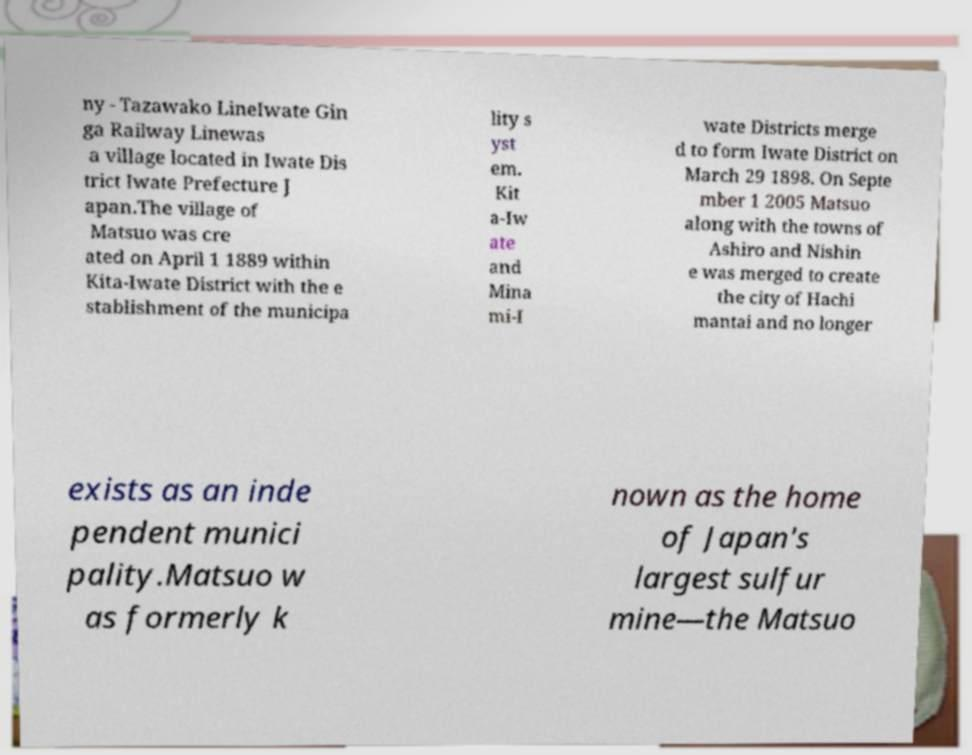For documentation purposes, I need the text within this image transcribed. Could you provide that? ny - Tazawako LineIwate Gin ga Railway Linewas a village located in Iwate Dis trict Iwate Prefecture J apan.The village of Matsuo was cre ated on April 1 1889 within Kita-Iwate District with the e stablishment of the municipa lity s yst em. Kit a-Iw ate and Mina mi-I wate Districts merge d to form Iwate District on March 29 1898. On Septe mber 1 2005 Matsuo along with the towns of Ashiro and Nishin e was merged to create the city of Hachi mantai and no longer exists as an inde pendent munici pality.Matsuo w as formerly k nown as the home of Japan's largest sulfur mine—the Matsuo 